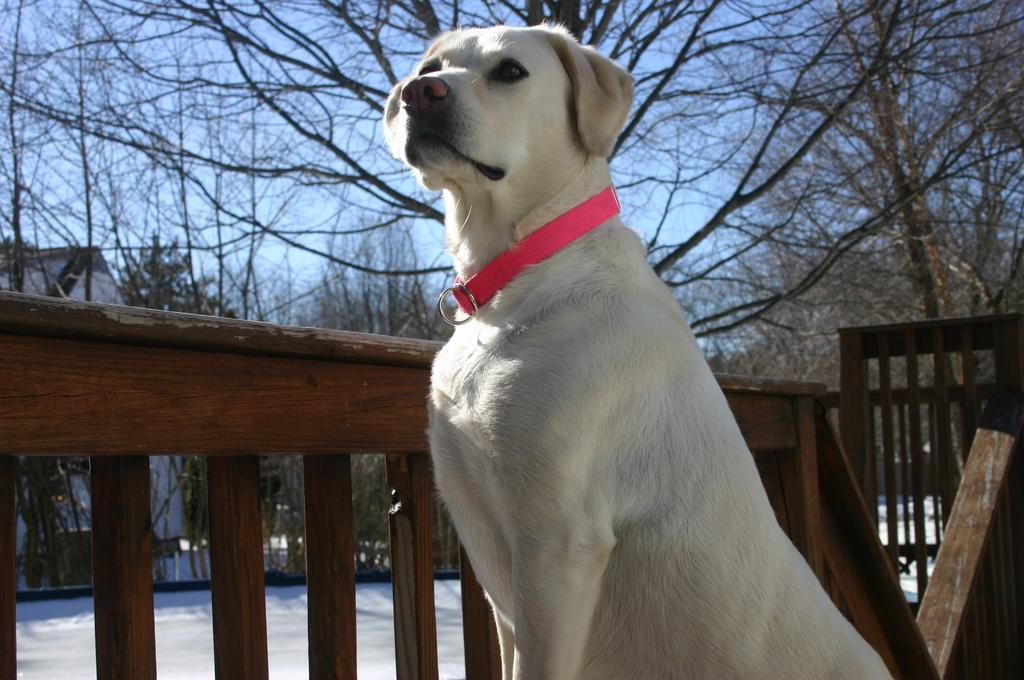What type of animal is in the picture? There is a dog in the picture. What distinguishes the dog in the picture? The dog has a pink belt around its neck and white fur. What can be seen in the background of the picture? There is a building and trees in the background of the picture. How many bulbs are hanging from the dog's collar in the image? There are no bulbs present in the image, and the dog's collar is adorned with a pink belt, not bulbs. What type of bird is sitting next to the dog in the image? There is no bird present in the image; it features only a dog with a pink belt and white fur. 